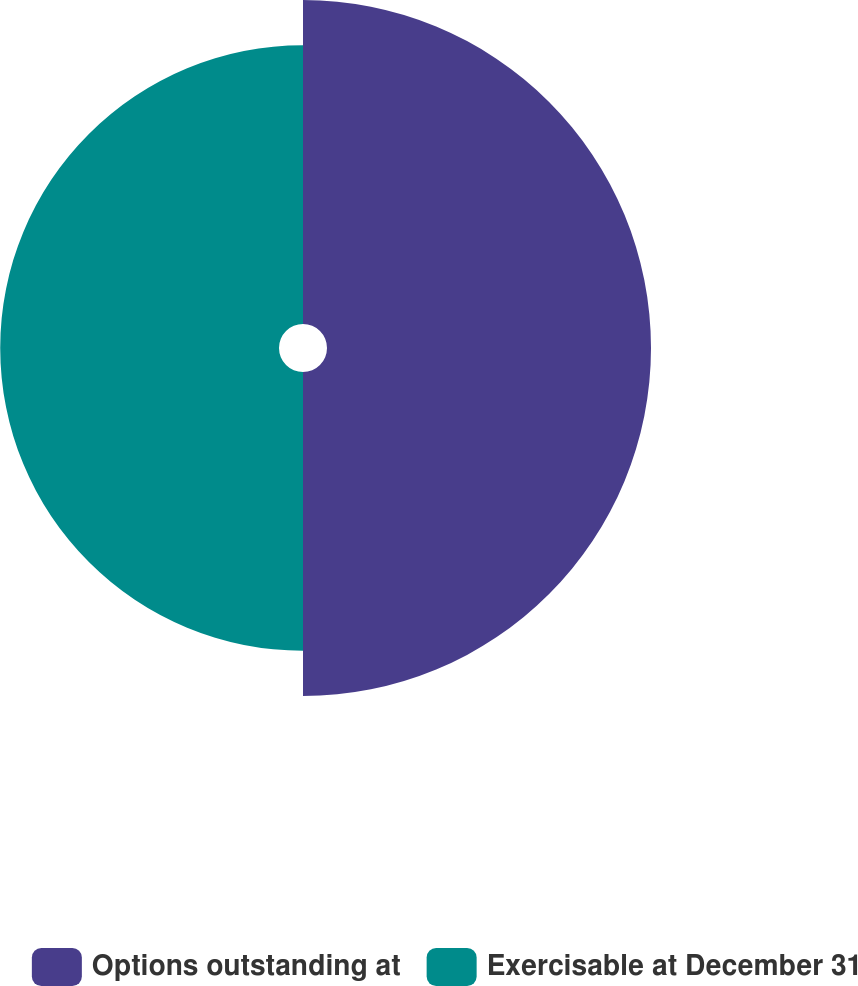Convert chart to OTSL. <chart><loc_0><loc_0><loc_500><loc_500><pie_chart><fcel>Options outstanding at<fcel>Exercisable at December 31<nl><fcel>53.75%<fcel>46.25%<nl></chart> 